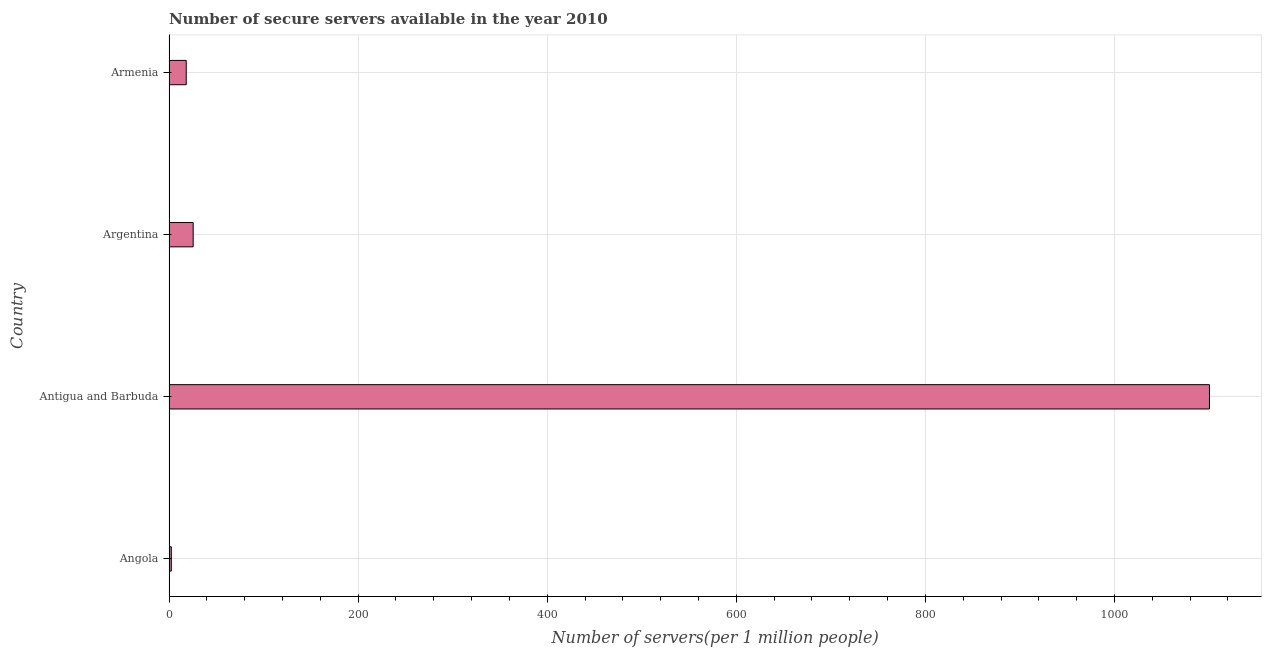What is the title of the graph?
Provide a succinct answer. Number of secure servers available in the year 2010. What is the label or title of the X-axis?
Offer a terse response. Number of servers(per 1 million people). What is the number of secure internet servers in Antigua and Barbuda?
Give a very brief answer. 1100.5. Across all countries, what is the maximum number of secure internet servers?
Keep it short and to the point. 1100.5. Across all countries, what is the minimum number of secure internet servers?
Your response must be concise. 2.45. In which country was the number of secure internet servers maximum?
Give a very brief answer. Antigua and Barbuda. In which country was the number of secure internet servers minimum?
Offer a terse response. Angola. What is the sum of the number of secure internet servers?
Your answer should be very brief. 1146.74. What is the difference between the number of secure internet servers in Angola and Armenia?
Offer a very short reply. -15.77. What is the average number of secure internet servers per country?
Your answer should be very brief. 286.69. What is the median number of secure internet servers?
Your answer should be very brief. 21.9. In how many countries, is the number of secure internet servers greater than 640 ?
Ensure brevity in your answer.  1. What is the ratio of the number of secure internet servers in Antigua and Barbuda to that in Armenia?
Provide a succinct answer. 60.4. Is the number of secure internet servers in Argentina less than that in Armenia?
Offer a terse response. No. Is the difference between the number of secure internet servers in Angola and Armenia greater than the difference between any two countries?
Ensure brevity in your answer.  No. What is the difference between the highest and the second highest number of secure internet servers?
Your response must be concise. 1074.93. Is the sum of the number of secure internet servers in Angola and Argentina greater than the maximum number of secure internet servers across all countries?
Provide a succinct answer. No. What is the difference between the highest and the lowest number of secure internet servers?
Make the answer very short. 1098.05. Are all the bars in the graph horizontal?
Keep it short and to the point. Yes. What is the difference between two consecutive major ticks on the X-axis?
Your response must be concise. 200. What is the Number of servers(per 1 million people) of Angola?
Your answer should be very brief. 2.45. What is the Number of servers(per 1 million people) in Antigua and Barbuda?
Your response must be concise. 1100.5. What is the Number of servers(per 1 million people) in Argentina?
Your response must be concise. 25.57. What is the Number of servers(per 1 million people) in Armenia?
Keep it short and to the point. 18.22. What is the difference between the Number of servers(per 1 million people) in Angola and Antigua and Barbuda?
Provide a succinct answer. -1098.05. What is the difference between the Number of servers(per 1 million people) in Angola and Argentina?
Your answer should be compact. -23.12. What is the difference between the Number of servers(per 1 million people) in Angola and Armenia?
Your answer should be compact. -15.77. What is the difference between the Number of servers(per 1 million people) in Antigua and Barbuda and Argentina?
Provide a succinct answer. 1074.93. What is the difference between the Number of servers(per 1 million people) in Antigua and Barbuda and Armenia?
Offer a very short reply. 1082.28. What is the difference between the Number of servers(per 1 million people) in Argentina and Armenia?
Provide a short and direct response. 7.35. What is the ratio of the Number of servers(per 1 million people) in Angola to that in Antigua and Barbuda?
Your response must be concise. 0. What is the ratio of the Number of servers(per 1 million people) in Angola to that in Argentina?
Offer a very short reply. 0.1. What is the ratio of the Number of servers(per 1 million people) in Angola to that in Armenia?
Keep it short and to the point. 0.13. What is the ratio of the Number of servers(per 1 million people) in Antigua and Barbuda to that in Argentina?
Your answer should be compact. 43.04. What is the ratio of the Number of servers(per 1 million people) in Antigua and Barbuda to that in Armenia?
Offer a terse response. 60.4. What is the ratio of the Number of servers(per 1 million people) in Argentina to that in Armenia?
Provide a short and direct response. 1.4. 